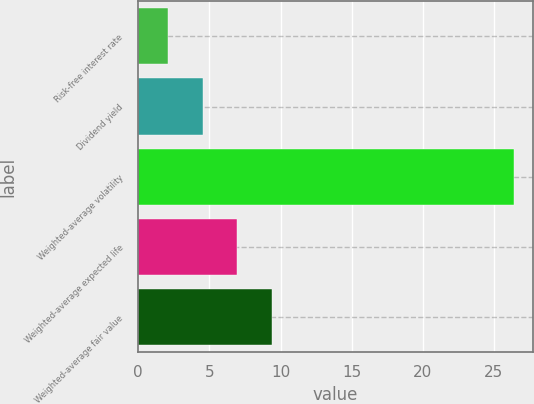Convert chart. <chart><loc_0><loc_0><loc_500><loc_500><bar_chart><fcel>Risk-free interest rate<fcel>Dividend yield<fcel>Weighted-average volatility<fcel>Weighted-average expected life<fcel>Weighted-average fair value<nl><fcel>2.1<fcel>4.53<fcel>26.4<fcel>6.96<fcel>9.39<nl></chart> 